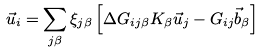<formula> <loc_0><loc_0><loc_500><loc_500>\vec { u } _ { i } = \sum _ { j \beta } \xi _ { j \beta } \left [ \Delta { G } _ { i j \beta } { K } _ { \beta } \vec { u } _ { j } - { G } _ { i j } \vec { b } _ { \beta } \right ]</formula> 